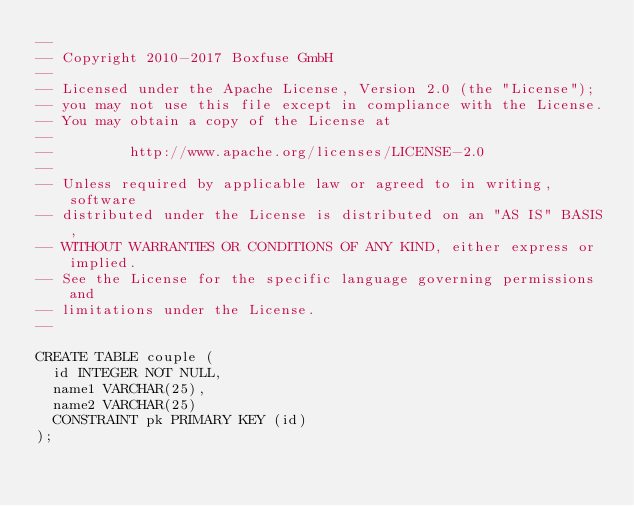<code> <loc_0><loc_0><loc_500><loc_500><_SQL_>--
-- Copyright 2010-2017 Boxfuse GmbH
--
-- Licensed under the Apache License, Version 2.0 (the "License");
-- you may not use this file except in compliance with the License.
-- You may obtain a copy of the License at
--
--         http://www.apache.org/licenses/LICENSE-2.0
--
-- Unless required by applicable law or agreed to in writing, software
-- distributed under the License is distributed on an "AS IS" BASIS,
-- WITHOUT WARRANTIES OR CONDITIONS OF ANY KIND, either express or implied.
-- See the License for the specific language governing permissions and
-- limitations under the License.
--

CREATE TABLE couple (
  id INTEGER NOT NULL,
  name1 VARCHAR(25),
  name2 VARCHAR(25)
  CONSTRAINT pk PRIMARY KEY (id)
);</code> 